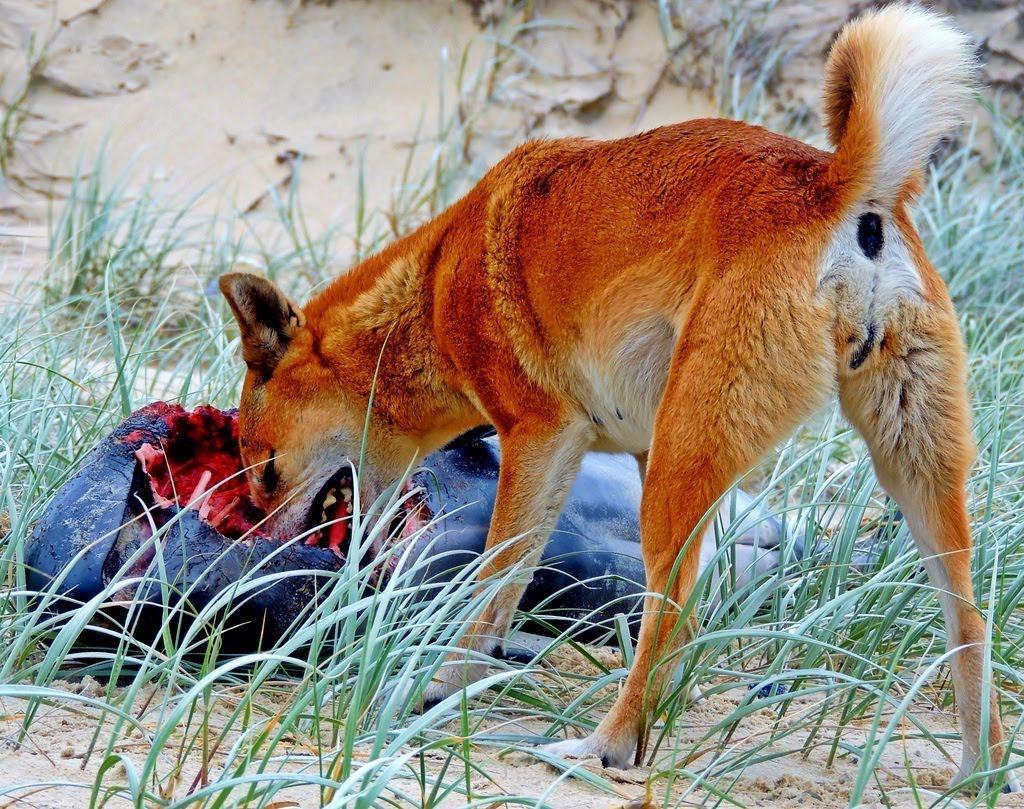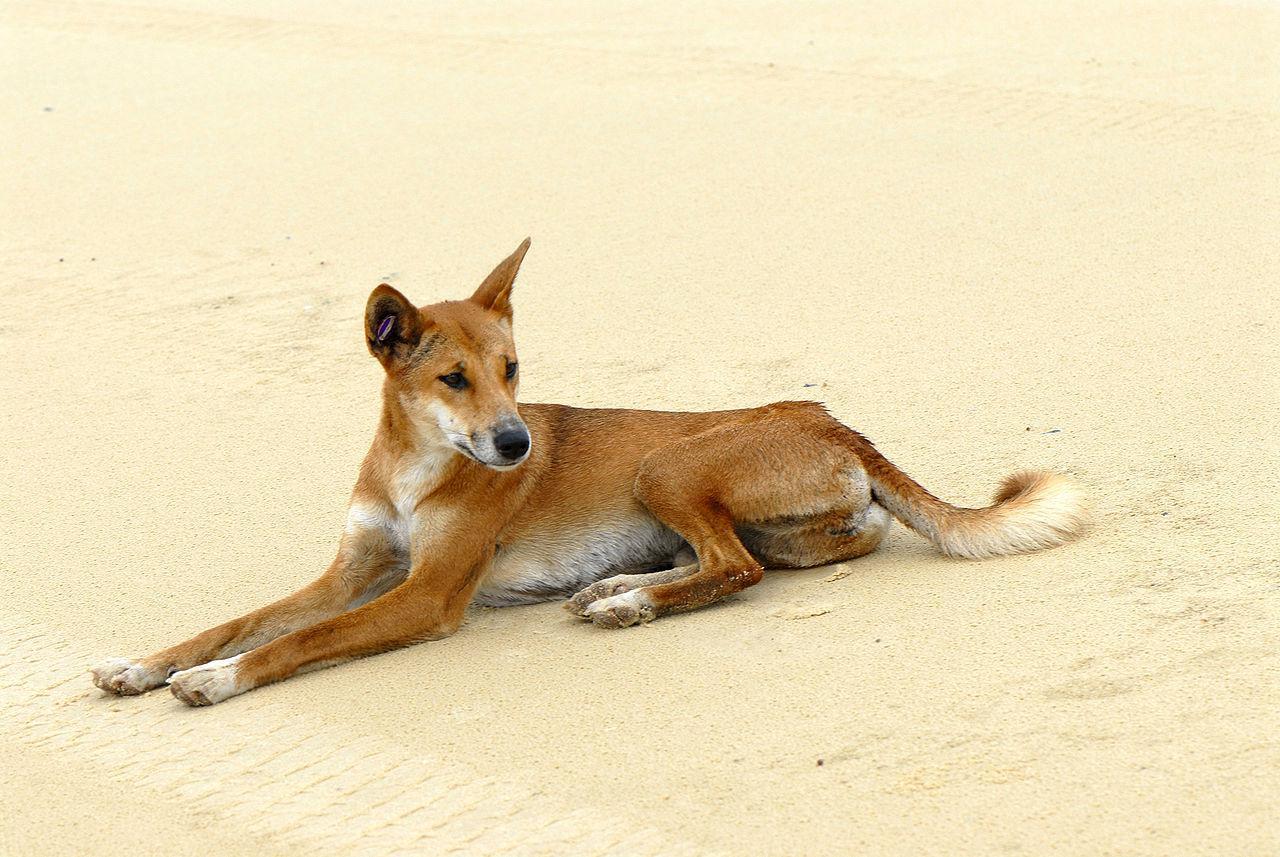The first image is the image on the left, the second image is the image on the right. For the images shown, is this caption "A wild dog is standing near a half eaten shark in the image on the right." true? Answer yes or no. No. 